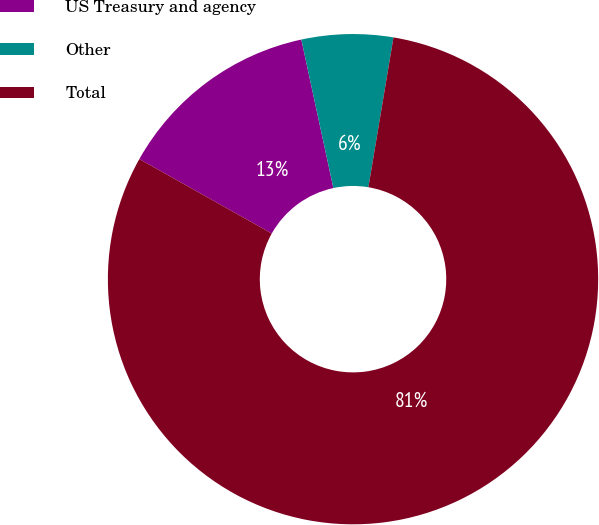<chart> <loc_0><loc_0><loc_500><loc_500><pie_chart><fcel>US Treasury and agency<fcel>Other<fcel>Total<nl><fcel>13.47%<fcel>6.02%<fcel>80.52%<nl></chart> 